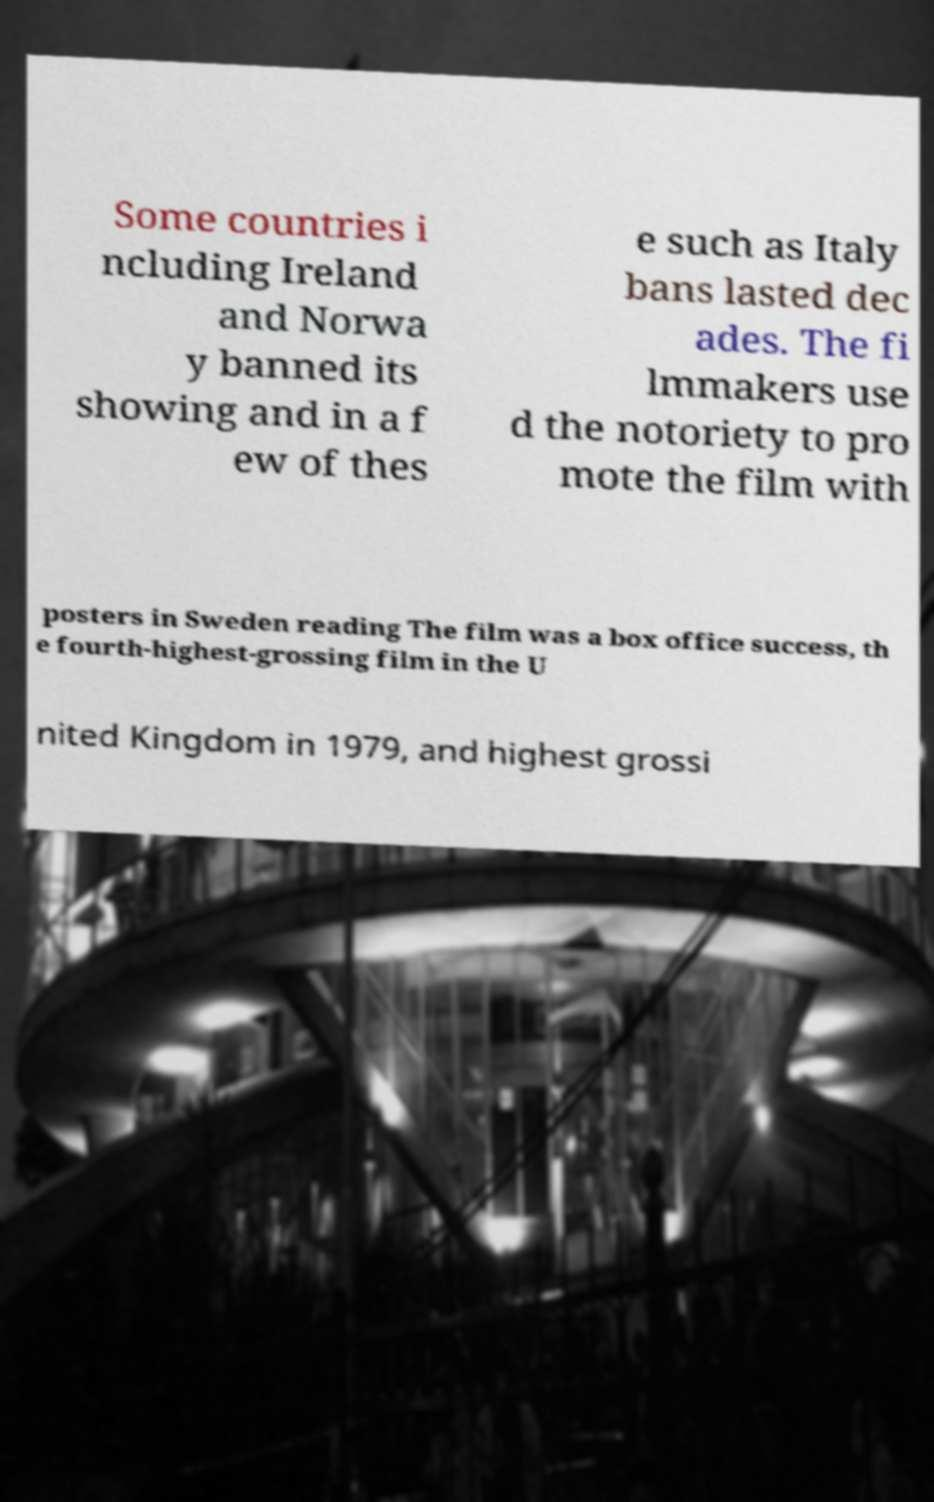Could you assist in decoding the text presented in this image and type it out clearly? Some countries i ncluding Ireland and Norwa y banned its showing and in a f ew of thes e such as Italy bans lasted dec ades. The fi lmmakers use d the notoriety to pro mote the film with posters in Sweden reading The film was a box office success, th e fourth-highest-grossing film in the U nited Kingdom in 1979, and highest grossi 